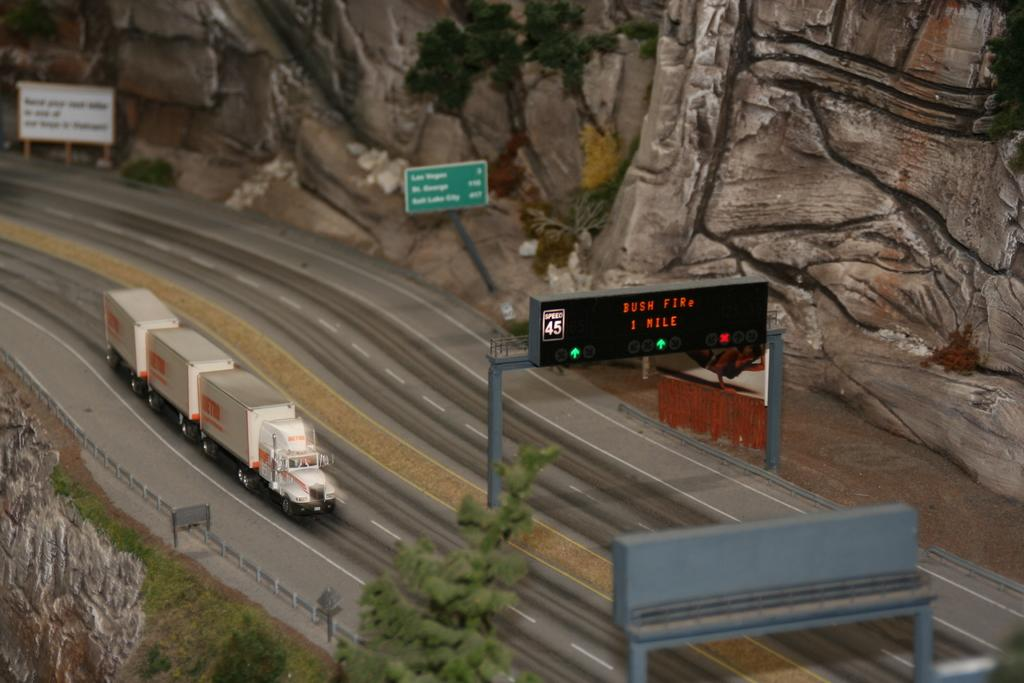What is the main subject of the image? There is a vehicle on the road in the image. What else can be seen in the image besides the vehicle? There are boards and trees visible in the image. What is present in the background of the image? There are rocks visible in the background of the image. What type of grape is being used to paint the boards in the image? There is no grape present in the image, nor is there any indication that the boards are being painted. 